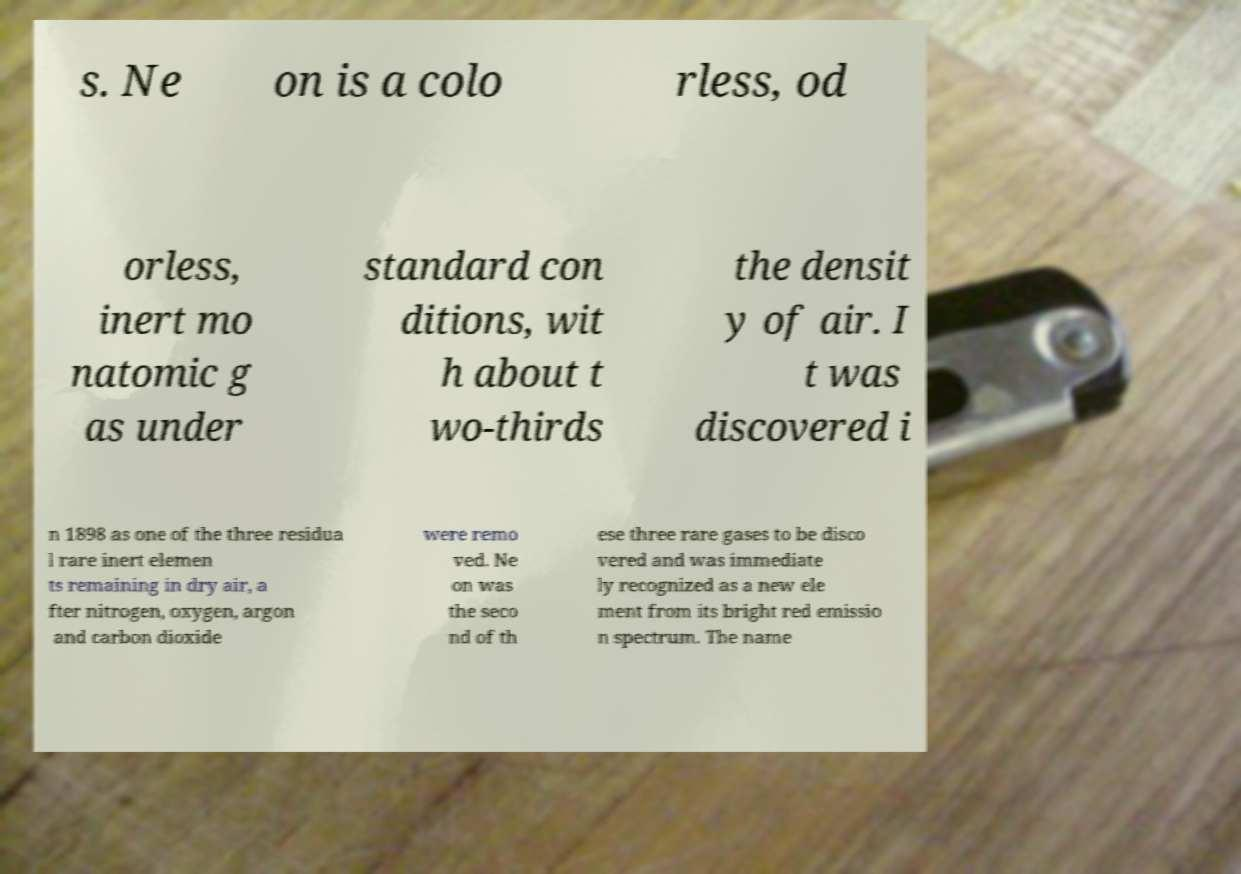Please read and relay the text visible in this image. What does it say? s. Ne on is a colo rless, od orless, inert mo natomic g as under standard con ditions, wit h about t wo-thirds the densit y of air. I t was discovered i n 1898 as one of the three residua l rare inert elemen ts remaining in dry air, a fter nitrogen, oxygen, argon and carbon dioxide were remo ved. Ne on was the seco nd of th ese three rare gases to be disco vered and was immediate ly recognized as a new ele ment from its bright red emissio n spectrum. The name 